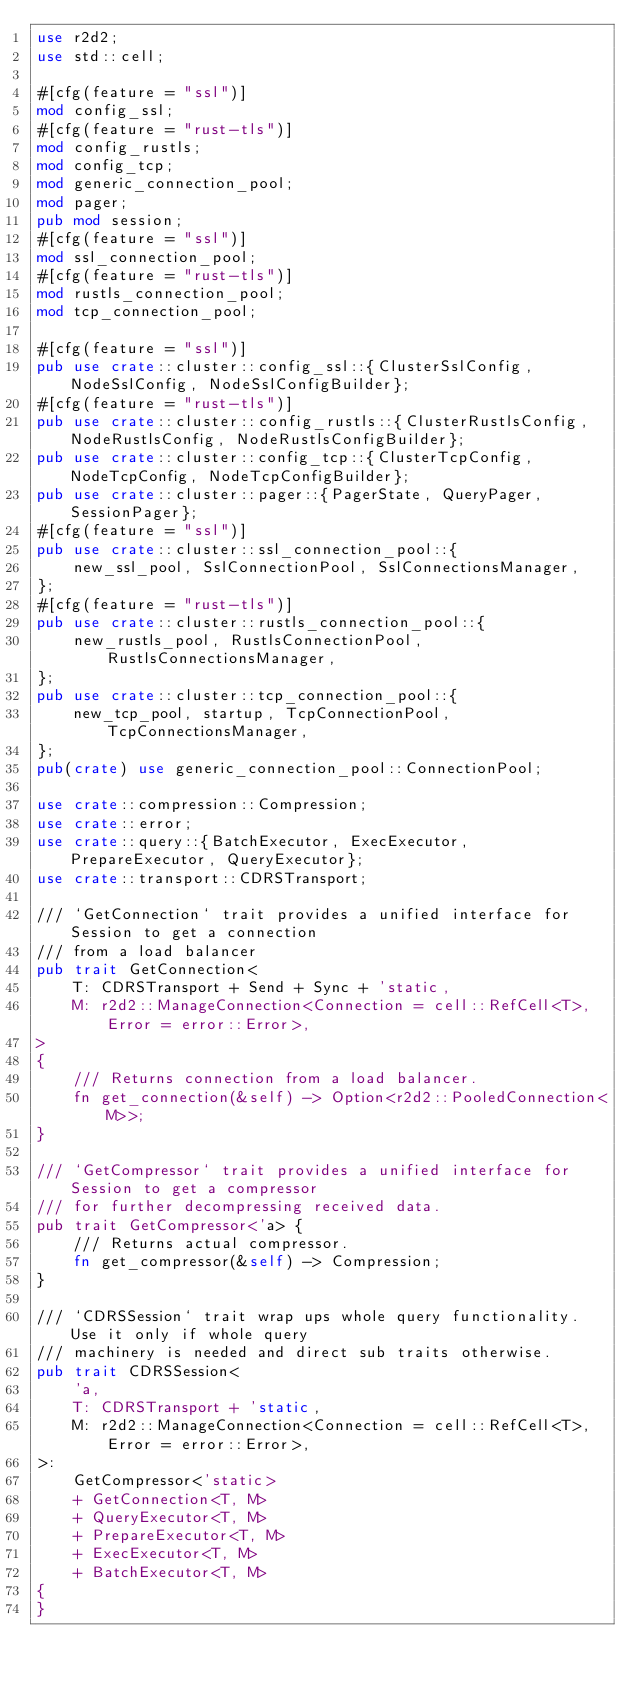<code> <loc_0><loc_0><loc_500><loc_500><_Rust_>use r2d2;
use std::cell;

#[cfg(feature = "ssl")]
mod config_ssl;
#[cfg(feature = "rust-tls")]
mod config_rustls;
mod config_tcp;
mod generic_connection_pool;
mod pager;
pub mod session;
#[cfg(feature = "ssl")]
mod ssl_connection_pool;
#[cfg(feature = "rust-tls")]
mod rustls_connection_pool;
mod tcp_connection_pool;

#[cfg(feature = "ssl")]
pub use crate::cluster::config_ssl::{ClusterSslConfig, NodeSslConfig, NodeSslConfigBuilder};
#[cfg(feature = "rust-tls")]
pub use crate::cluster::config_rustls::{ClusterRustlsConfig, NodeRustlsConfig, NodeRustlsConfigBuilder};
pub use crate::cluster::config_tcp::{ClusterTcpConfig, NodeTcpConfig, NodeTcpConfigBuilder};
pub use crate::cluster::pager::{PagerState, QueryPager, SessionPager};
#[cfg(feature = "ssl")]
pub use crate::cluster::ssl_connection_pool::{
    new_ssl_pool, SslConnectionPool, SslConnectionsManager,
};
#[cfg(feature = "rust-tls")]
pub use crate::cluster::rustls_connection_pool::{
    new_rustls_pool, RustlsConnectionPool, RustlsConnectionsManager,
};
pub use crate::cluster::tcp_connection_pool::{
    new_tcp_pool, startup, TcpConnectionPool, TcpConnectionsManager,
};
pub(crate) use generic_connection_pool::ConnectionPool;

use crate::compression::Compression;
use crate::error;
use crate::query::{BatchExecutor, ExecExecutor, PrepareExecutor, QueryExecutor};
use crate::transport::CDRSTransport;

/// `GetConnection` trait provides a unified interface for Session to get a connection
/// from a load balancer
pub trait GetConnection<
    T: CDRSTransport + Send + Sync + 'static,
    M: r2d2::ManageConnection<Connection = cell::RefCell<T>, Error = error::Error>,
>
{
    /// Returns connection from a load balancer.
    fn get_connection(&self) -> Option<r2d2::PooledConnection<M>>;
}

/// `GetCompressor` trait provides a unified interface for Session to get a compressor
/// for further decompressing received data.
pub trait GetCompressor<'a> {
    /// Returns actual compressor.
    fn get_compressor(&self) -> Compression;
}

/// `CDRSSession` trait wrap ups whole query functionality. Use it only if whole query
/// machinery is needed and direct sub traits otherwise.
pub trait CDRSSession<
    'a,
    T: CDRSTransport + 'static,
    M: r2d2::ManageConnection<Connection = cell::RefCell<T>, Error = error::Error>,
>:
    GetCompressor<'static>
    + GetConnection<T, M>
    + QueryExecutor<T, M>
    + PrepareExecutor<T, M>
    + ExecExecutor<T, M>
    + BatchExecutor<T, M>
{
}
</code> 